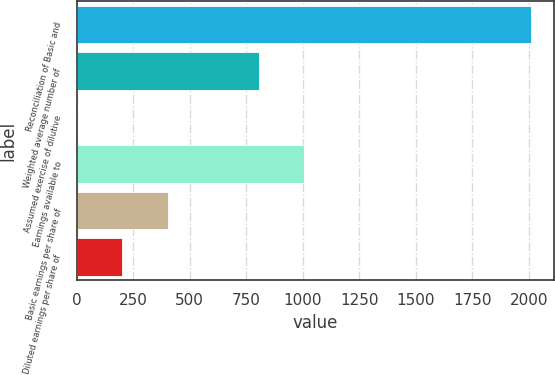Convert chart. <chart><loc_0><loc_0><loc_500><loc_500><bar_chart><fcel>Reconciliation of Basic and<fcel>Weighted average number of<fcel>Assumed exercise of dilutive<fcel>Earnings available to<fcel>Basic earnings per share of<fcel>Diluted earnings per share of<nl><fcel>2010<fcel>804.6<fcel>1<fcel>1005.5<fcel>402.8<fcel>201.9<nl></chart> 